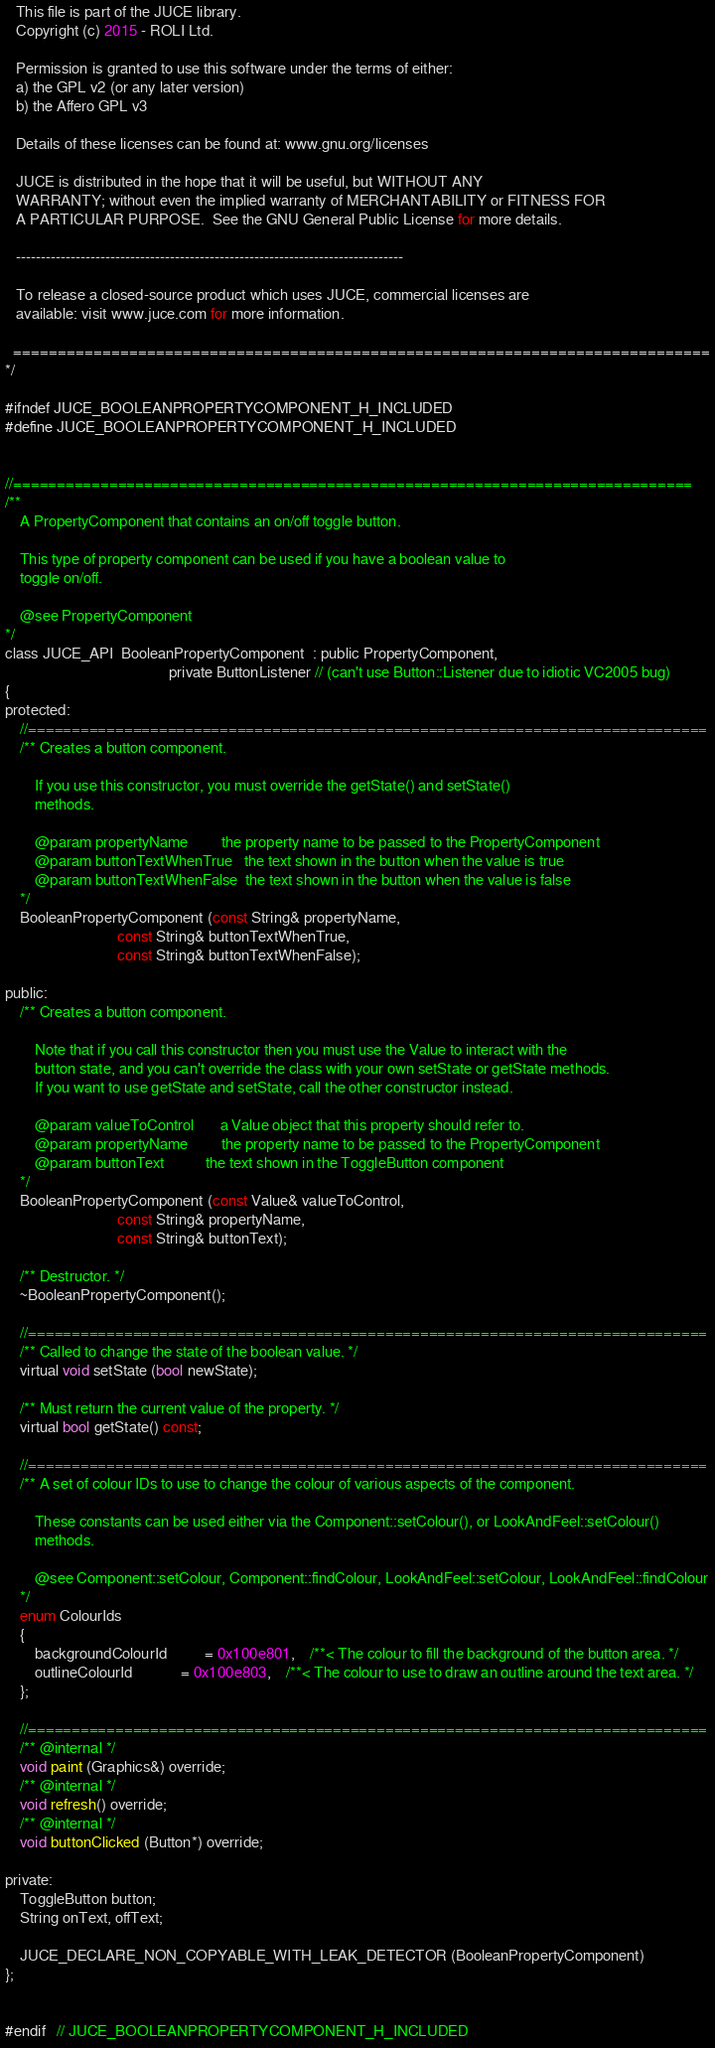<code> <loc_0><loc_0><loc_500><loc_500><_C_>   This file is part of the JUCE library.
   Copyright (c) 2015 - ROLI Ltd.

   Permission is granted to use this software under the terms of either:
   a) the GPL v2 (or any later version)
   b) the Affero GPL v3

   Details of these licenses can be found at: www.gnu.org/licenses

   JUCE is distributed in the hope that it will be useful, but WITHOUT ANY
   WARRANTY; without even the implied warranty of MERCHANTABILITY or FITNESS FOR
   A PARTICULAR PURPOSE.  See the GNU General Public License for more details.

   ------------------------------------------------------------------------------

   To release a closed-source product which uses JUCE, commercial licenses are
   available: visit www.juce.com for more information.

  ==============================================================================
*/

#ifndef JUCE_BOOLEANPROPERTYCOMPONENT_H_INCLUDED
#define JUCE_BOOLEANPROPERTYCOMPONENT_H_INCLUDED


//==============================================================================
/**
    A PropertyComponent that contains an on/off toggle button.

    This type of property component can be used if you have a boolean value to
    toggle on/off.

    @see PropertyComponent
*/
class JUCE_API  BooleanPropertyComponent  : public PropertyComponent,
                                            private ButtonListener // (can't use Button::Listener due to idiotic VC2005 bug)
{
protected:
    //==============================================================================
    /** Creates a button component.

        If you use this constructor, you must override the getState() and setState()
        methods.

        @param propertyName         the property name to be passed to the PropertyComponent
        @param buttonTextWhenTrue   the text shown in the button when the value is true
        @param buttonTextWhenFalse  the text shown in the button when the value is false
    */
    BooleanPropertyComponent (const String& propertyName,
                              const String& buttonTextWhenTrue,
                              const String& buttonTextWhenFalse);

public:
    /** Creates a button component.

        Note that if you call this constructor then you must use the Value to interact with the
        button state, and you can't override the class with your own setState or getState methods.
        If you want to use getState and setState, call the other constructor instead.

        @param valueToControl       a Value object that this property should refer to.
        @param propertyName         the property name to be passed to the PropertyComponent
        @param buttonText           the text shown in the ToggleButton component
    */
    BooleanPropertyComponent (const Value& valueToControl,
                              const String& propertyName,
                              const String& buttonText);

    /** Destructor. */
    ~BooleanPropertyComponent();

    //==============================================================================
    /** Called to change the state of the boolean value. */
    virtual void setState (bool newState);

    /** Must return the current value of the property. */
    virtual bool getState() const;

    //==============================================================================
    /** A set of colour IDs to use to change the colour of various aspects of the component.

        These constants can be used either via the Component::setColour(), or LookAndFeel::setColour()
        methods.

        @see Component::setColour, Component::findColour, LookAndFeel::setColour, LookAndFeel::findColour
    */
    enum ColourIds
    {
        backgroundColourId          = 0x100e801,    /**< The colour to fill the background of the button area. */
        outlineColourId             = 0x100e803,    /**< The colour to use to draw an outline around the text area. */
    };

    //==============================================================================
    /** @internal */
    void paint (Graphics&) override;
    /** @internal */
    void refresh() override;
    /** @internal */
    void buttonClicked (Button*) override;

private:
    ToggleButton button;
    String onText, offText;

    JUCE_DECLARE_NON_COPYABLE_WITH_LEAK_DETECTOR (BooleanPropertyComponent)
};


#endif   // JUCE_BOOLEANPROPERTYCOMPONENT_H_INCLUDED
</code> 